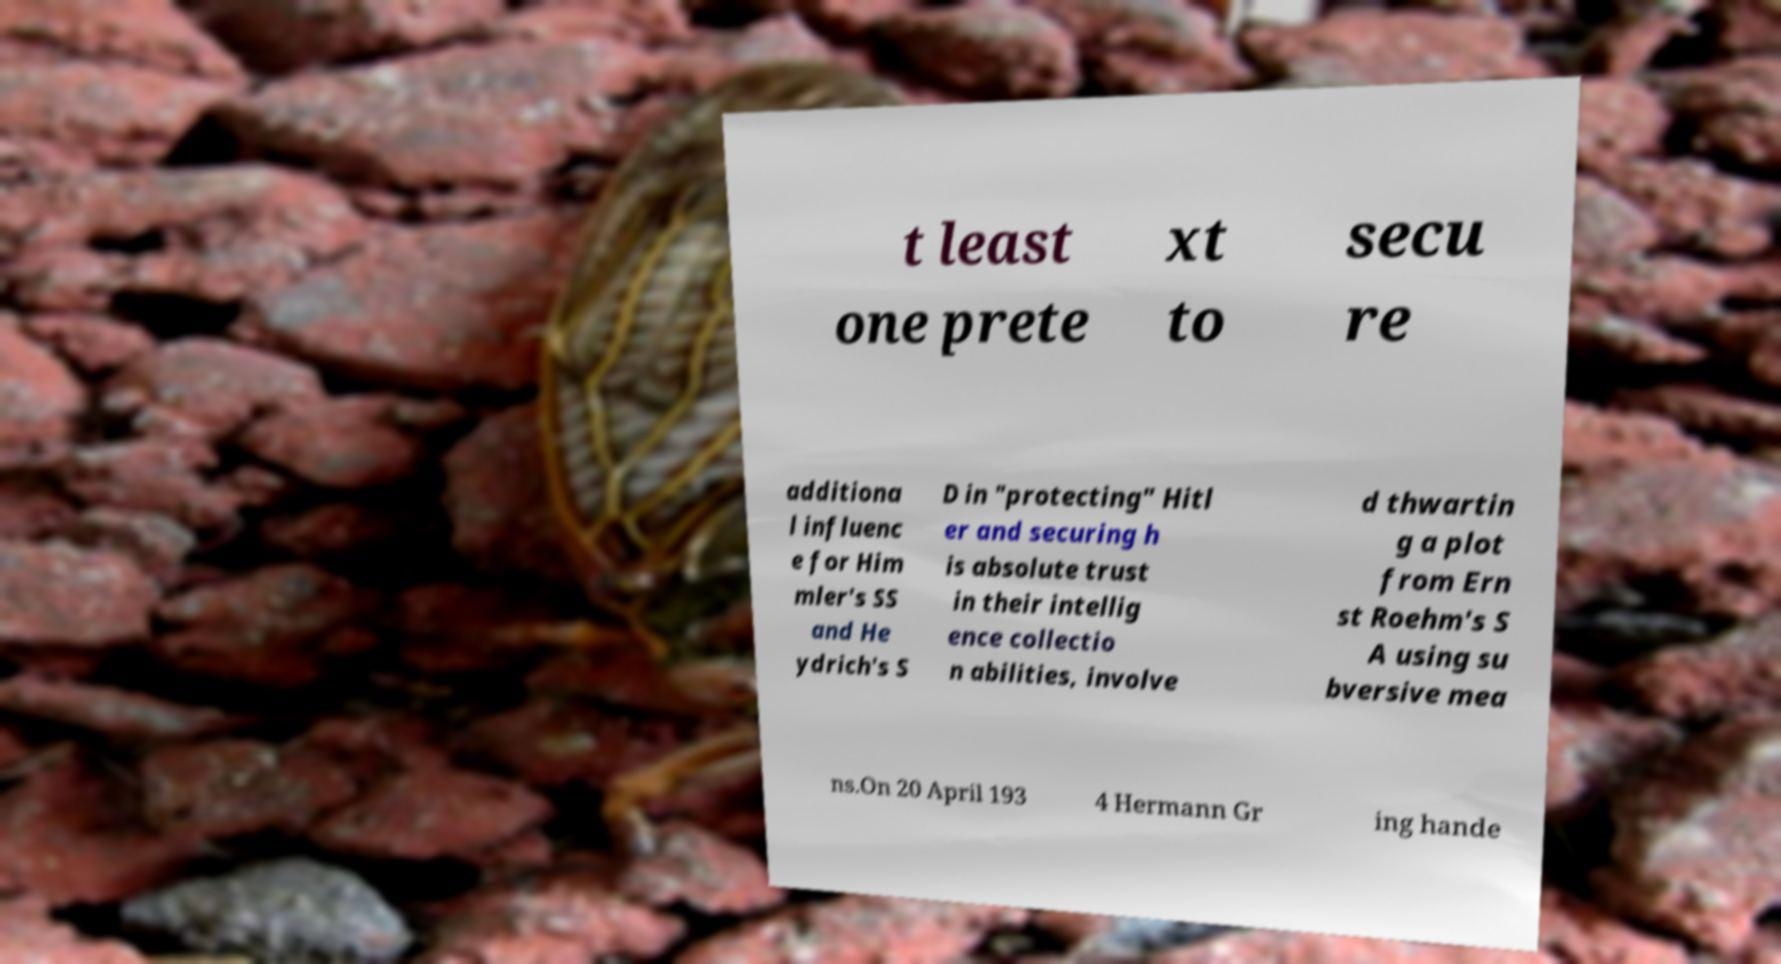There's text embedded in this image that I need extracted. Can you transcribe it verbatim? t least one prete xt to secu re additiona l influenc e for Him mler's SS and He ydrich's S D in "protecting" Hitl er and securing h is absolute trust in their intellig ence collectio n abilities, involve d thwartin g a plot from Ern st Roehm's S A using su bversive mea ns.On 20 April 193 4 Hermann Gr ing hande 